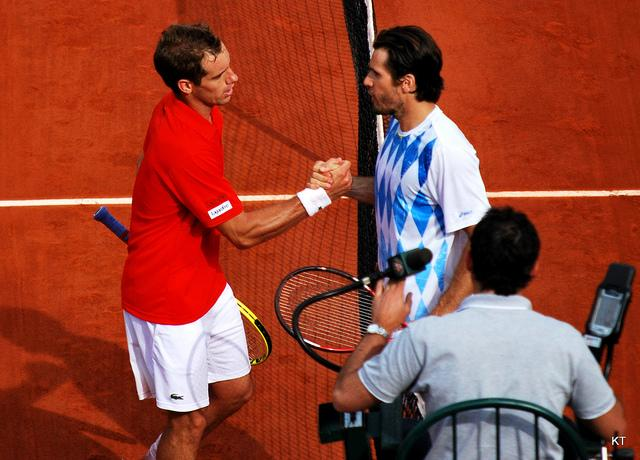What is the man in the chair known as? referee 